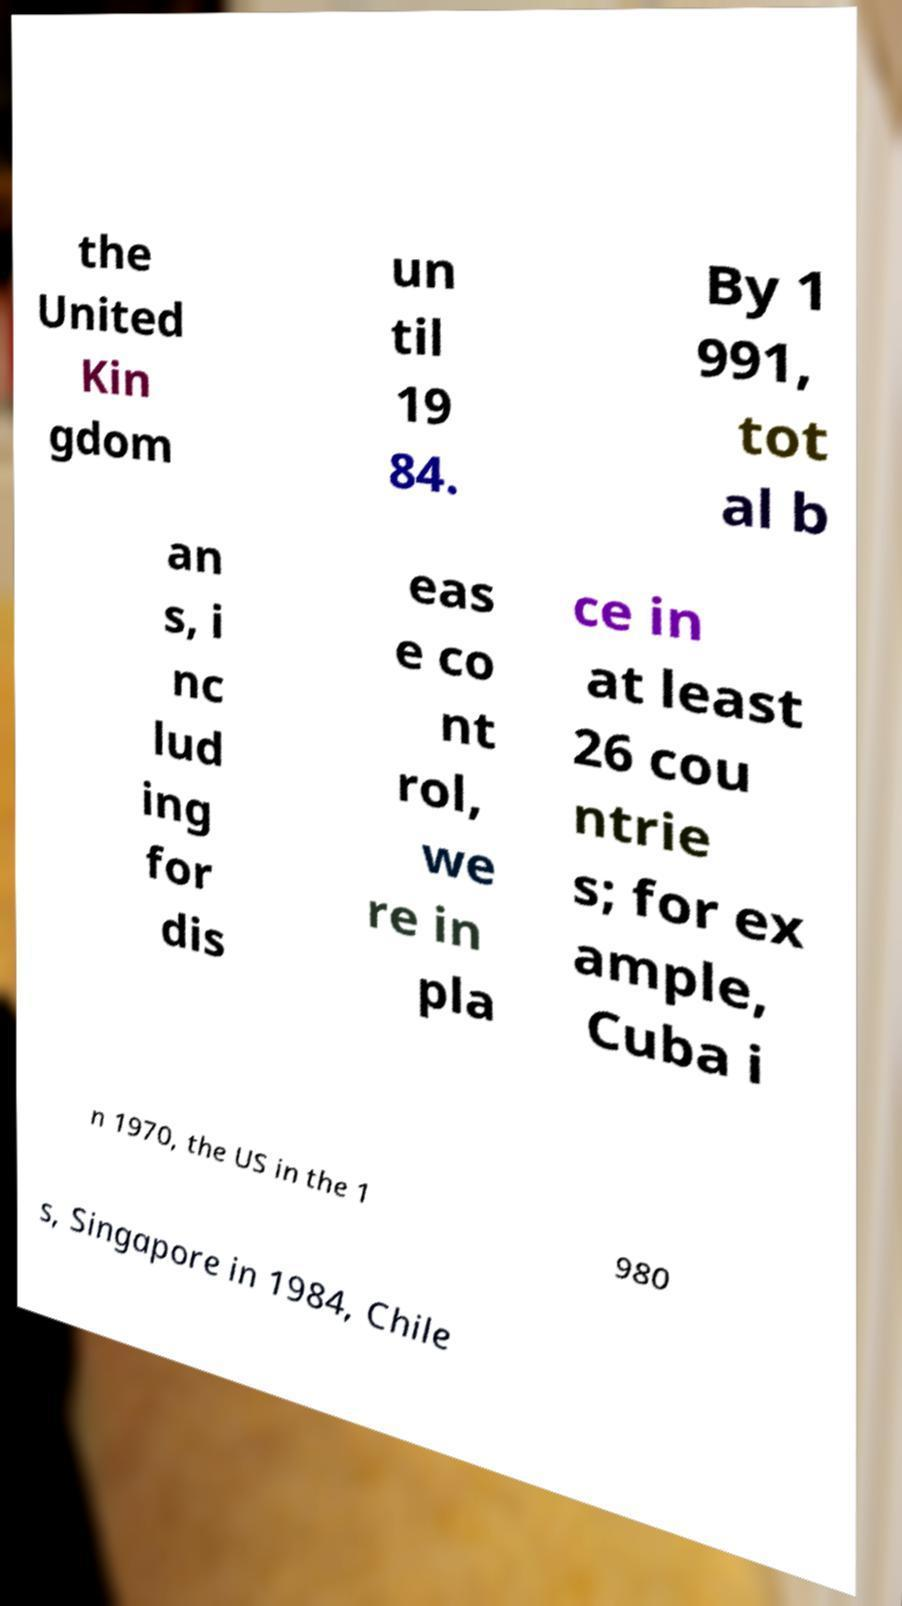Please identify and transcribe the text found in this image. the United Kin gdom un til 19 84. By 1 991, tot al b an s, i nc lud ing for dis eas e co nt rol, we re in pla ce in at least 26 cou ntrie s; for ex ample, Cuba i n 1970, the US in the 1 980 s, Singapore in 1984, Chile 